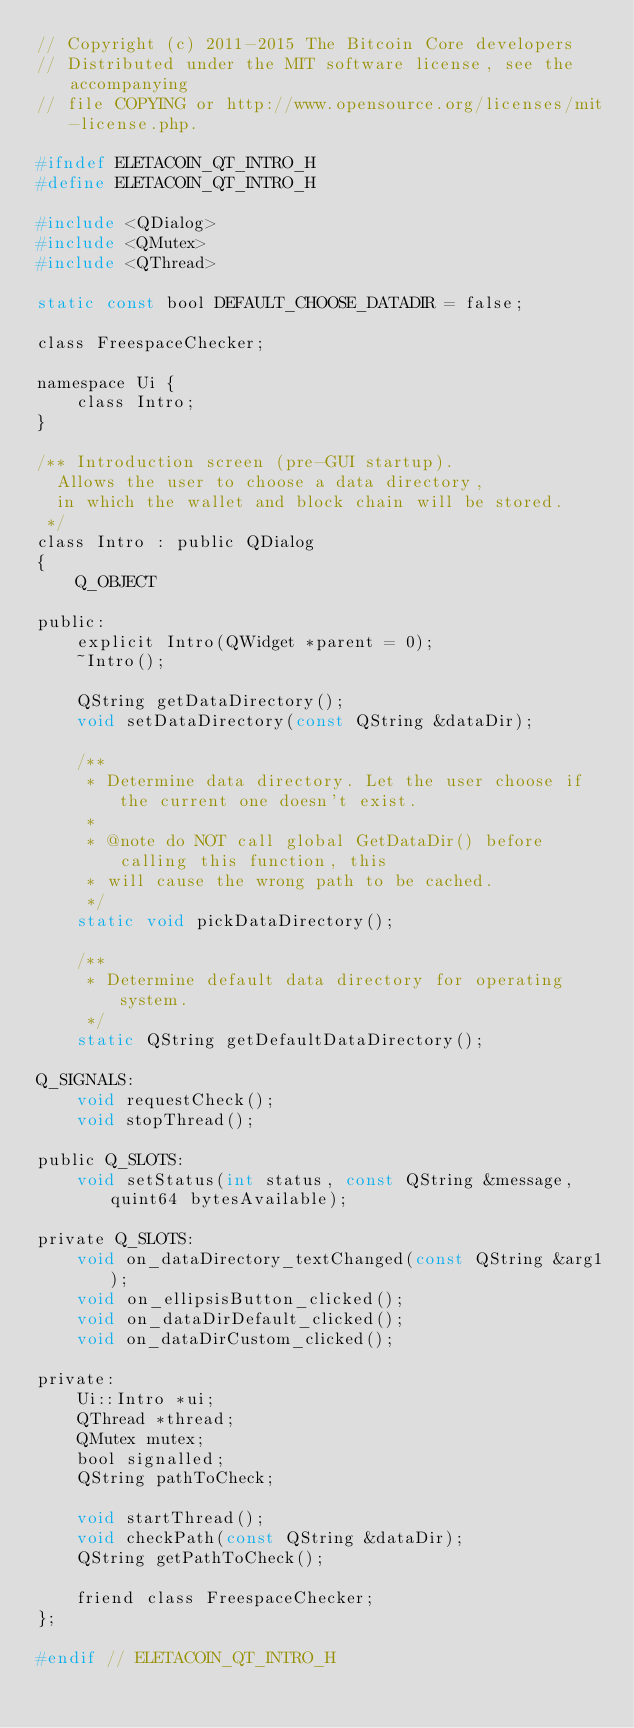Convert code to text. <code><loc_0><loc_0><loc_500><loc_500><_C_>// Copyright (c) 2011-2015 The Bitcoin Core developers
// Distributed under the MIT software license, see the accompanying
// file COPYING or http://www.opensource.org/licenses/mit-license.php.

#ifndef ELETACOIN_QT_INTRO_H
#define ELETACOIN_QT_INTRO_H

#include <QDialog>
#include <QMutex>
#include <QThread>

static const bool DEFAULT_CHOOSE_DATADIR = false;

class FreespaceChecker;

namespace Ui {
    class Intro;
}

/** Introduction screen (pre-GUI startup).
  Allows the user to choose a data directory,
  in which the wallet and block chain will be stored.
 */
class Intro : public QDialog
{
    Q_OBJECT

public:
    explicit Intro(QWidget *parent = 0);
    ~Intro();

    QString getDataDirectory();
    void setDataDirectory(const QString &dataDir);

    /**
     * Determine data directory. Let the user choose if the current one doesn't exist.
     *
     * @note do NOT call global GetDataDir() before calling this function, this
     * will cause the wrong path to be cached.
     */
    static void pickDataDirectory();

    /**
     * Determine default data directory for operating system.
     */
    static QString getDefaultDataDirectory();

Q_SIGNALS:
    void requestCheck();
    void stopThread();

public Q_SLOTS:
    void setStatus(int status, const QString &message, quint64 bytesAvailable);

private Q_SLOTS:
    void on_dataDirectory_textChanged(const QString &arg1);
    void on_ellipsisButton_clicked();
    void on_dataDirDefault_clicked();
    void on_dataDirCustom_clicked();

private:
    Ui::Intro *ui;
    QThread *thread;
    QMutex mutex;
    bool signalled;
    QString pathToCheck;

    void startThread();
    void checkPath(const QString &dataDir);
    QString getPathToCheck();

    friend class FreespaceChecker;
};

#endif // ELETACOIN_QT_INTRO_H
</code> 